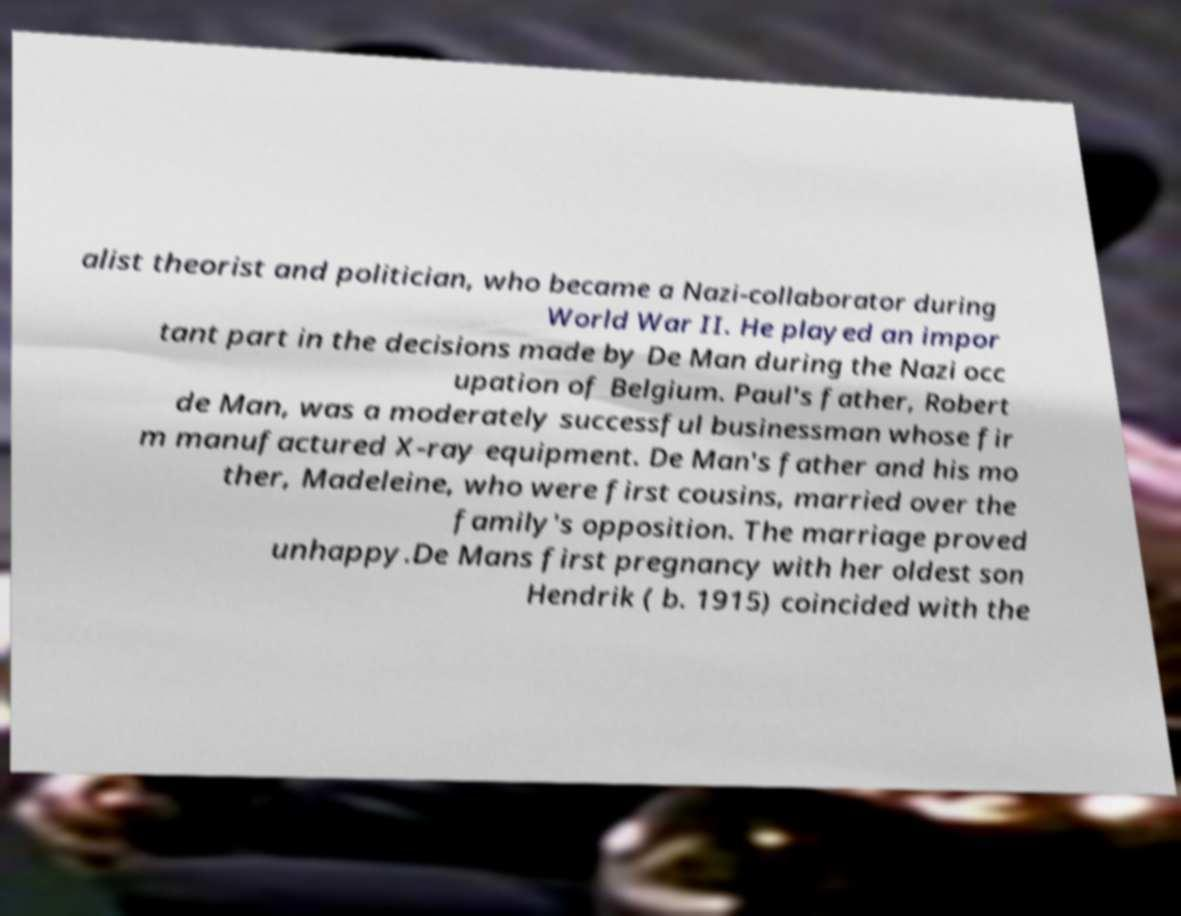There's text embedded in this image that I need extracted. Can you transcribe it verbatim? alist theorist and politician, who became a Nazi-collaborator during World War II. He played an impor tant part in the decisions made by De Man during the Nazi occ upation of Belgium. Paul's father, Robert de Man, was a moderately successful businessman whose fir m manufactured X-ray equipment. De Man's father and his mo ther, Madeleine, who were first cousins, married over the family's opposition. The marriage proved unhappy.De Mans first pregnancy with her oldest son Hendrik ( b. 1915) coincided with the 